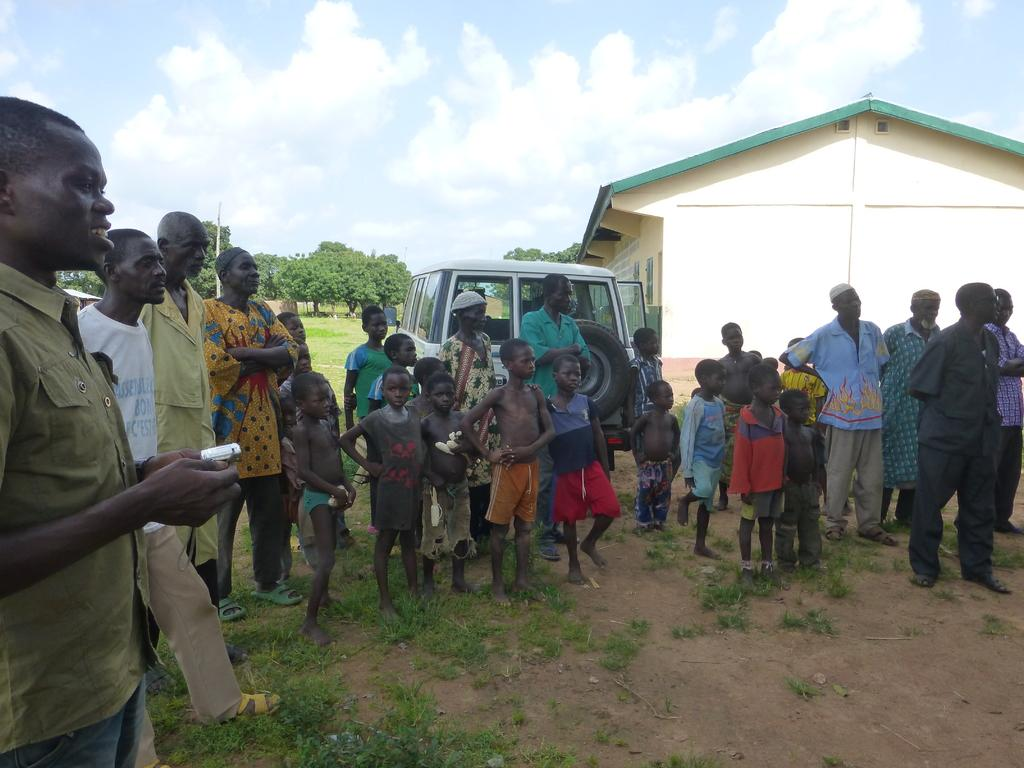What are the people in the image doing? The people in the image are standing on the ground. What can be seen in the background of the image? The sky with clouds, at least one building, a motor vehicle, trees, and grass are visible in the background. What type of snake can be seen slithering through the grass in the image? There is no snake present in the image; the grass is visible in the background, but no snake can be seen. 